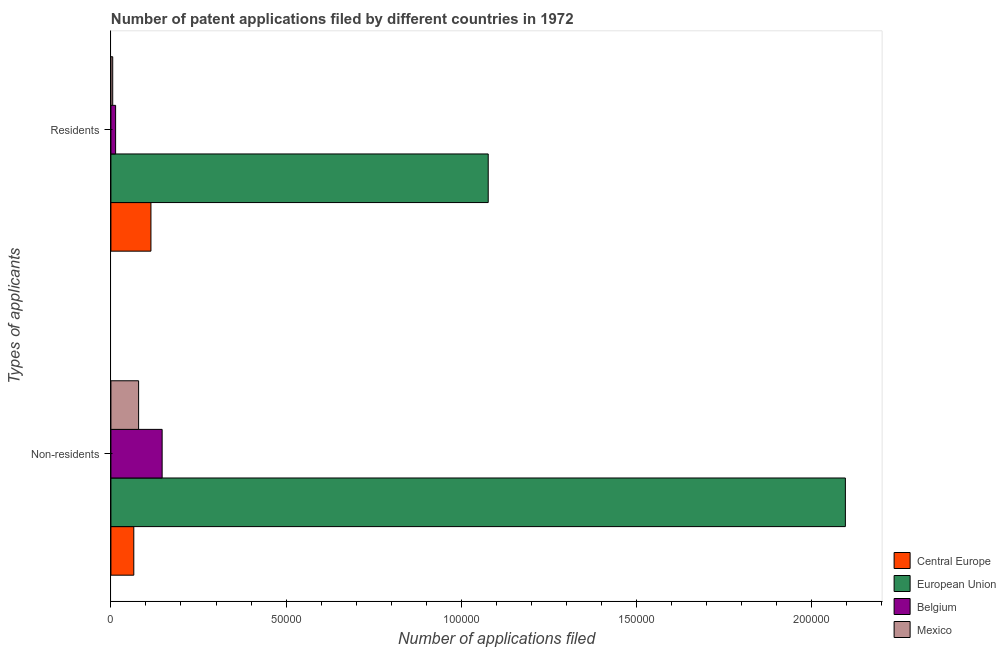Are the number of bars per tick equal to the number of legend labels?
Provide a succinct answer. Yes. Are the number of bars on each tick of the Y-axis equal?
Offer a terse response. Yes. What is the label of the 1st group of bars from the top?
Offer a terse response. Residents. What is the number of patent applications by residents in Central Europe?
Your answer should be compact. 1.14e+04. Across all countries, what is the maximum number of patent applications by non residents?
Offer a very short reply. 2.10e+05. Across all countries, what is the minimum number of patent applications by non residents?
Ensure brevity in your answer.  6531. In which country was the number of patent applications by residents minimum?
Offer a terse response. Mexico. What is the total number of patent applications by residents in the graph?
Keep it short and to the point. 1.21e+05. What is the difference between the number of patent applications by residents in Mexico and that in European Union?
Provide a short and direct response. -1.07e+05. What is the difference between the number of patent applications by residents in Belgium and the number of patent applications by non residents in Central Europe?
Keep it short and to the point. -5189. What is the average number of patent applications by non residents per country?
Your answer should be very brief. 5.97e+04. What is the difference between the number of patent applications by non residents and number of patent applications by residents in Central Europe?
Offer a very short reply. -4892. What is the ratio of the number of patent applications by residents in Mexico to that in Central Europe?
Your response must be concise. 0.04. In how many countries, is the number of patent applications by residents greater than the average number of patent applications by residents taken over all countries?
Your response must be concise. 1. What does the 4th bar from the top in Residents represents?
Ensure brevity in your answer.  Central Europe. How many bars are there?
Provide a succinct answer. 8. Are all the bars in the graph horizontal?
Your answer should be very brief. Yes. How many countries are there in the graph?
Keep it short and to the point. 4. What is the difference between two consecutive major ticks on the X-axis?
Offer a very short reply. 5.00e+04. Are the values on the major ticks of X-axis written in scientific E-notation?
Ensure brevity in your answer.  No. Does the graph contain any zero values?
Provide a succinct answer. No. Where does the legend appear in the graph?
Offer a very short reply. Bottom right. What is the title of the graph?
Ensure brevity in your answer.  Number of patent applications filed by different countries in 1972. Does "Serbia" appear as one of the legend labels in the graph?
Provide a short and direct response. No. What is the label or title of the X-axis?
Offer a very short reply. Number of applications filed. What is the label or title of the Y-axis?
Make the answer very short. Types of applicants. What is the Number of applications filed in Central Europe in Non-residents?
Ensure brevity in your answer.  6531. What is the Number of applications filed of European Union in Non-residents?
Offer a very short reply. 2.10e+05. What is the Number of applications filed of Belgium in Non-residents?
Give a very brief answer. 1.46e+04. What is the Number of applications filed in Mexico in Non-residents?
Your answer should be compact. 7907. What is the Number of applications filed in Central Europe in Residents?
Make the answer very short. 1.14e+04. What is the Number of applications filed in European Union in Residents?
Give a very brief answer. 1.08e+05. What is the Number of applications filed of Belgium in Residents?
Make the answer very short. 1342. What is the Number of applications filed of Mexico in Residents?
Provide a succinct answer. 513. Across all Types of applicants, what is the maximum Number of applications filed of Central Europe?
Provide a succinct answer. 1.14e+04. Across all Types of applicants, what is the maximum Number of applications filed of European Union?
Provide a succinct answer. 2.10e+05. Across all Types of applicants, what is the maximum Number of applications filed in Belgium?
Your answer should be compact. 1.46e+04. Across all Types of applicants, what is the maximum Number of applications filed of Mexico?
Ensure brevity in your answer.  7907. Across all Types of applicants, what is the minimum Number of applications filed of Central Europe?
Give a very brief answer. 6531. Across all Types of applicants, what is the minimum Number of applications filed of European Union?
Your response must be concise. 1.08e+05. Across all Types of applicants, what is the minimum Number of applications filed in Belgium?
Provide a short and direct response. 1342. Across all Types of applicants, what is the minimum Number of applications filed of Mexico?
Keep it short and to the point. 513. What is the total Number of applications filed in Central Europe in the graph?
Your answer should be very brief. 1.80e+04. What is the total Number of applications filed of European Union in the graph?
Give a very brief answer. 3.17e+05. What is the total Number of applications filed of Belgium in the graph?
Provide a succinct answer. 1.60e+04. What is the total Number of applications filed in Mexico in the graph?
Make the answer very short. 8420. What is the difference between the Number of applications filed in Central Europe in Non-residents and that in Residents?
Give a very brief answer. -4892. What is the difference between the Number of applications filed in European Union in Non-residents and that in Residents?
Provide a short and direct response. 1.02e+05. What is the difference between the Number of applications filed of Belgium in Non-residents and that in Residents?
Offer a terse response. 1.33e+04. What is the difference between the Number of applications filed of Mexico in Non-residents and that in Residents?
Keep it short and to the point. 7394. What is the difference between the Number of applications filed of Central Europe in Non-residents and the Number of applications filed of European Union in Residents?
Offer a terse response. -1.01e+05. What is the difference between the Number of applications filed in Central Europe in Non-residents and the Number of applications filed in Belgium in Residents?
Offer a terse response. 5189. What is the difference between the Number of applications filed in Central Europe in Non-residents and the Number of applications filed in Mexico in Residents?
Your answer should be compact. 6018. What is the difference between the Number of applications filed of European Union in Non-residents and the Number of applications filed of Belgium in Residents?
Provide a succinct answer. 2.08e+05. What is the difference between the Number of applications filed of European Union in Non-residents and the Number of applications filed of Mexico in Residents?
Your response must be concise. 2.09e+05. What is the difference between the Number of applications filed in Belgium in Non-residents and the Number of applications filed in Mexico in Residents?
Provide a succinct answer. 1.41e+04. What is the average Number of applications filed of Central Europe per Types of applicants?
Give a very brief answer. 8977. What is the average Number of applications filed of European Union per Types of applicants?
Offer a terse response. 1.59e+05. What is the average Number of applications filed of Belgium per Types of applicants?
Give a very brief answer. 7981. What is the average Number of applications filed of Mexico per Types of applicants?
Make the answer very short. 4210. What is the difference between the Number of applications filed of Central Europe and Number of applications filed of European Union in Non-residents?
Offer a terse response. -2.03e+05. What is the difference between the Number of applications filed in Central Europe and Number of applications filed in Belgium in Non-residents?
Your response must be concise. -8089. What is the difference between the Number of applications filed of Central Europe and Number of applications filed of Mexico in Non-residents?
Ensure brevity in your answer.  -1376. What is the difference between the Number of applications filed in European Union and Number of applications filed in Belgium in Non-residents?
Make the answer very short. 1.95e+05. What is the difference between the Number of applications filed of European Union and Number of applications filed of Mexico in Non-residents?
Your answer should be compact. 2.02e+05. What is the difference between the Number of applications filed in Belgium and Number of applications filed in Mexico in Non-residents?
Provide a short and direct response. 6713. What is the difference between the Number of applications filed of Central Europe and Number of applications filed of European Union in Residents?
Ensure brevity in your answer.  -9.63e+04. What is the difference between the Number of applications filed in Central Europe and Number of applications filed in Belgium in Residents?
Make the answer very short. 1.01e+04. What is the difference between the Number of applications filed of Central Europe and Number of applications filed of Mexico in Residents?
Provide a succinct answer. 1.09e+04. What is the difference between the Number of applications filed of European Union and Number of applications filed of Belgium in Residents?
Make the answer very short. 1.06e+05. What is the difference between the Number of applications filed in European Union and Number of applications filed in Mexico in Residents?
Offer a very short reply. 1.07e+05. What is the difference between the Number of applications filed in Belgium and Number of applications filed in Mexico in Residents?
Your answer should be compact. 829. What is the ratio of the Number of applications filed in Central Europe in Non-residents to that in Residents?
Ensure brevity in your answer.  0.57. What is the ratio of the Number of applications filed of European Union in Non-residents to that in Residents?
Offer a terse response. 1.95. What is the ratio of the Number of applications filed in Belgium in Non-residents to that in Residents?
Provide a short and direct response. 10.89. What is the ratio of the Number of applications filed in Mexico in Non-residents to that in Residents?
Provide a short and direct response. 15.41. What is the difference between the highest and the second highest Number of applications filed in Central Europe?
Your answer should be very brief. 4892. What is the difference between the highest and the second highest Number of applications filed of European Union?
Offer a very short reply. 1.02e+05. What is the difference between the highest and the second highest Number of applications filed in Belgium?
Give a very brief answer. 1.33e+04. What is the difference between the highest and the second highest Number of applications filed of Mexico?
Provide a short and direct response. 7394. What is the difference between the highest and the lowest Number of applications filed in Central Europe?
Your answer should be very brief. 4892. What is the difference between the highest and the lowest Number of applications filed of European Union?
Your response must be concise. 1.02e+05. What is the difference between the highest and the lowest Number of applications filed in Belgium?
Offer a very short reply. 1.33e+04. What is the difference between the highest and the lowest Number of applications filed in Mexico?
Provide a short and direct response. 7394. 